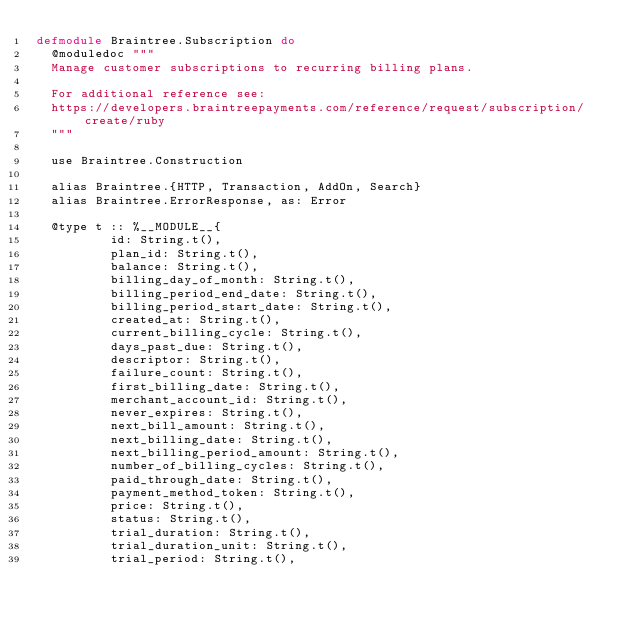<code> <loc_0><loc_0><loc_500><loc_500><_Elixir_>defmodule Braintree.Subscription do
  @moduledoc """
  Manage customer subscriptions to recurring billing plans.

  For additional reference see:
  https://developers.braintreepayments.com/reference/request/subscription/create/ruby
  """

  use Braintree.Construction

  alias Braintree.{HTTP, Transaction, AddOn, Search}
  alias Braintree.ErrorResponse, as: Error

  @type t :: %__MODULE__{
          id: String.t(),
          plan_id: String.t(),
          balance: String.t(),
          billing_day_of_month: String.t(),
          billing_period_end_date: String.t(),
          billing_period_start_date: String.t(),
          created_at: String.t(),
          current_billing_cycle: String.t(),
          days_past_due: String.t(),
          descriptor: String.t(),
          failure_count: String.t(),
          first_billing_date: String.t(),
          merchant_account_id: String.t(),
          never_expires: String.t(),
          next_bill_amount: String.t(),
          next_billing_date: String.t(),
          next_billing_period_amount: String.t(),
          number_of_billing_cycles: String.t(),
          paid_through_date: String.t(),
          payment_method_token: String.t(),
          price: String.t(),
          status: String.t(),
          trial_duration: String.t(),
          trial_duration_unit: String.t(),
          trial_period: String.t(),</code> 